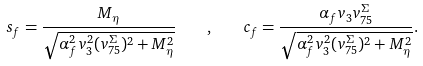<formula> <loc_0><loc_0><loc_500><loc_500>s _ { f } = \frac { M _ { \eta } } { \sqrt { \alpha _ { f } ^ { 2 } v _ { 3 } ^ { 2 } ( v ^ { \Sigma } _ { 7 5 } ) ^ { 2 } + M _ { \eta } ^ { 2 } } } \quad , \quad c _ { f } = \frac { \alpha _ { f } v _ { 3 } v ^ { \Sigma } _ { 7 5 } } { \sqrt { \alpha _ { f } ^ { 2 } v _ { 3 } ^ { 2 } ( v ^ { \Sigma } _ { 7 5 } ) ^ { 2 } + M _ { \eta } ^ { 2 } } } .</formula> 